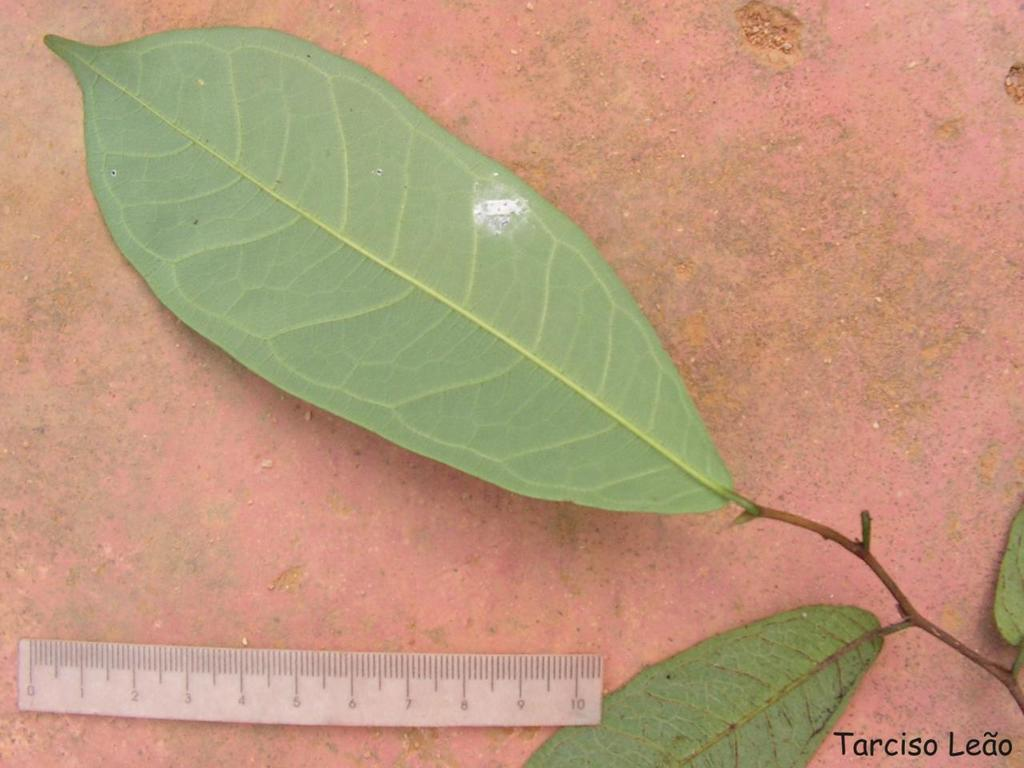<image>
Render a clear and concise summary of the photo. A couple of leaves  next to a rules  from Tarciso Leao. 